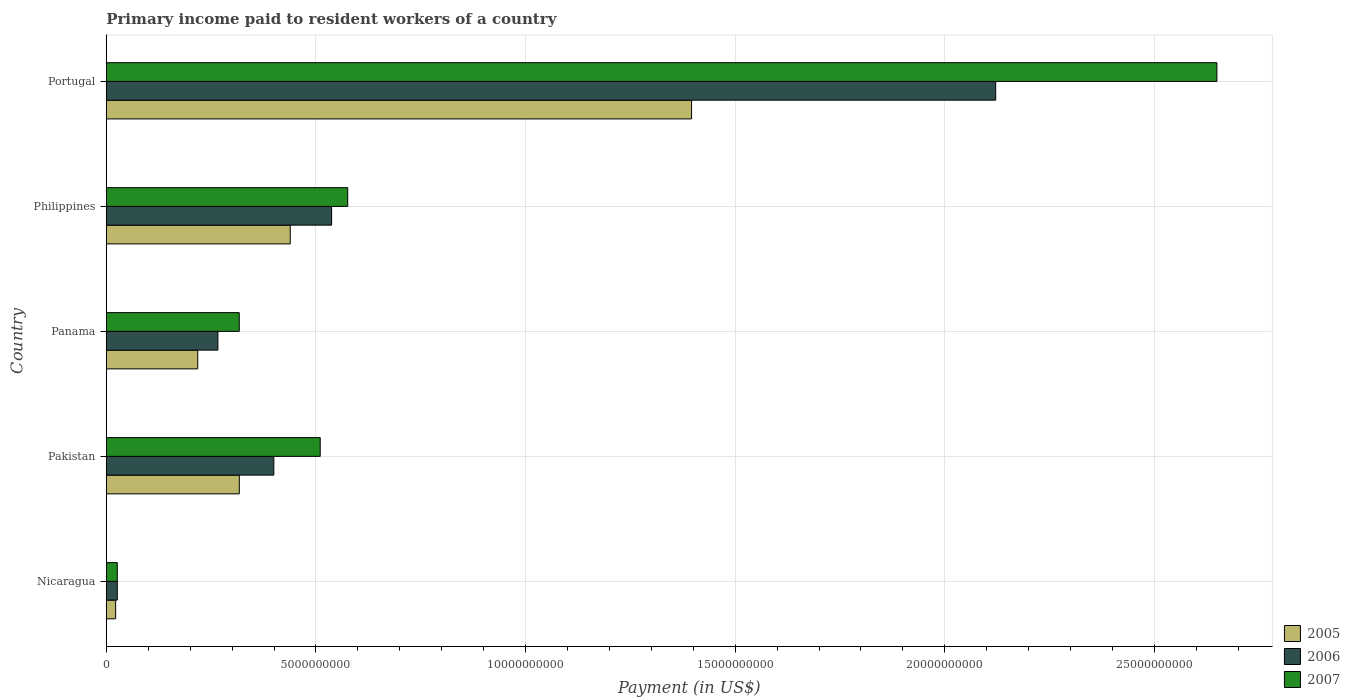How many groups of bars are there?
Your answer should be compact. 5. Are the number of bars per tick equal to the number of legend labels?
Your answer should be very brief. Yes. Are the number of bars on each tick of the Y-axis equal?
Ensure brevity in your answer.  Yes. How many bars are there on the 3rd tick from the top?
Offer a terse response. 3. In how many cases, is the number of bars for a given country not equal to the number of legend labels?
Keep it short and to the point. 0. What is the amount paid to workers in 2006 in Panama?
Offer a very short reply. 2.66e+09. Across all countries, what is the maximum amount paid to workers in 2007?
Keep it short and to the point. 2.65e+1. Across all countries, what is the minimum amount paid to workers in 2005?
Your response must be concise. 2.22e+08. In which country was the amount paid to workers in 2005 maximum?
Offer a very short reply. Portugal. In which country was the amount paid to workers in 2007 minimum?
Your answer should be very brief. Nicaragua. What is the total amount paid to workers in 2007 in the graph?
Give a very brief answer. 4.08e+1. What is the difference between the amount paid to workers in 2006 in Panama and that in Philippines?
Offer a very short reply. -2.71e+09. What is the difference between the amount paid to workers in 2007 in Pakistan and the amount paid to workers in 2006 in Portugal?
Your answer should be very brief. -1.61e+1. What is the average amount paid to workers in 2006 per country?
Keep it short and to the point. 6.70e+09. What is the difference between the amount paid to workers in 2005 and amount paid to workers in 2007 in Pakistan?
Offer a very short reply. -1.93e+09. What is the ratio of the amount paid to workers in 2005 in Pakistan to that in Philippines?
Your response must be concise. 0.72. What is the difference between the highest and the second highest amount paid to workers in 2007?
Provide a succinct answer. 2.07e+1. What is the difference between the highest and the lowest amount paid to workers in 2007?
Offer a very short reply. 2.62e+1. What does the 1st bar from the top in Pakistan represents?
Offer a terse response. 2007. What does the 2nd bar from the bottom in Portugal represents?
Provide a succinct answer. 2006. How many bars are there?
Your response must be concise. 15. What is the difference between two consecutive major ticks on the X-axis?
Provide a short and direct response. 5.00e+09. Are the values on the major ticks of X-axis written in scientific E-notation?
Your answer should be very brief. No. Does the graph contain any zero values?
Ensure brevity in your answer.  No. Where does the legend appear in the graph?
Give a very brief answer. Bottom right. How many legend labels are there?
Your response must be concise. 3. What is the title of the graph?
Keep it short and to the point. Primary income paid to resident workers of a country. Does "1987" appear as one of the legend labels in the graph?
Give a very brief answer. No. What is the label or title of the X-axis?
Keep it short and to the point. Payment (in US$). What is the Payment (in US$) in 2005 in Nicaragua?
Make the answer very short. 2.22e+08. What is the Payment (in US$) in 2006 in Nicaragua?
Provide a succinct answer. 2.62e+08. What is the Payment (in US$) of 2007 in Nicaragua?
Offer a very short reply. 2.61e+08. What is the Payment (in US$) of 2005 in Pakistan?
Provide a succinct answer. 3.17e+09. What is the Payment (in US$) of 2006 in Pakistan?
Offer a terse response. 4.00e+09. What is the Payment (in US$) in 2007 in Pakistan?
Make the answer very short. 5.10e+09. What is the Payment (in US$) in 2005 in Panama?
Offer a very short reply. 2.18e+09. What is the Payment (in US$) in 2006 in Panama?
Your answer should be very brief. 2.66e+09. What is the Payment (in US$) of 2007 in Panama?
Ensure brevity in your answer.  3.17e+09. What is the Payment (in US$) in 2005 in Philippines?
Ensure brevity in your answer.  4.39e+09. What is the Payment (in US$) in 2006 in Philippines?
Offer a terse response. 5.37e+09. What is the Payment (in US$) of 2007 in Philippines?
Offer a terse response. 5.76e+09. What is the Payment (in US$) in 2005 in Portugal?
Offer a very short reply. 1.40e+1. What is the Payment (in US$) in 2006 in Portugal?
Your response must be concise. 2.12e+1. What is the Payment (in US$) of 2007 in Portugal?
Provide a succinct answer. 2.65e+1. Across all countries, what is the maximum Payment (in US$) in 2005?
Provide a succinct answer. 1.40e+1. Across all countries, what is the maximum Payment (in US$) in 2006?
Ensure brevity in your answer.  2.12e+1. Across all countries, what is the maximum Payment (in US$) in 2007?
Provide a short and direct response. 2.65e+1. Across all countries, what is the minimum Payment (in US$) in 2005?
Give a very brief answer. 2.22e+08. Across all countries, what is the minimum Payment (in US$) of 2006?
Keep it short and to the point. 2.62e+08. Across all countries, what is the minimum Payment (in US$) in 2007?
Provide a short and direct response. 2.61e+08. What is the total Payment (in US$) of 2005 in the graph?
Your answer should be very brief. 2.39e+1. What is the total Payment (in US$) in 2006 in the graph?
Offer a very short reply. 3.35e+1. What is the total Payment (in US$) of 2007 in the graph?
Offer a terse response. 4.08e+1. What is the difference between the Payment (in US$) in 2005 in Nicaragua and that in Pakistan?
Make the answer very short. -2.95e+09. What is the difference between the Payment (in US$) of 2006 in Nicaragua and that in Pakistan?
Offer a very short reply. -3.73e+09. What is the difference between the Payment (in US$) in 2007 in Nicaragua and that in Pakistan?
Offer a very short reply. -4.84e+09. What is the difference between the Payment (in US$) of 2005 in Nicaragua and that in Panama?
Offer a terse response. -1.96e+09. What is the difference between the Payment (in US$) of 2006 in Nicaragua and that in Panama?
Offer a terse response. -2.40e+09. What is the difference between the Payment (in US$) in 2007 in Nicaragua and that in Panama?
Keep it short and to the point. -2.91e+09. What is the difference between the Payment (in US$) in 2005 in Nicaragua and that in Philippines?
Provide a succinct answer. -4.17e+09. What is the difference between the Payment (in US$) of 2006 in Nicaragua and that in Philippines?
Offer a very short reply. -5.11e+09. What is the difference between the Payment (in US$) of 2007 in Nicaragua and that in Philippines?
Offer a terse response. -5.50e+09. What is the difference between the Payment (in US$) of 2005 in Nicaragua and that in Portugal?
Your answer should be very brief. -1.37e+1. What is the difference between the Payment (in US$) of 2006 in Nicaragua and that in Portugal?
Offer a terse response. -2.10e+1. What is the difference between the Payment (in US$) of 2007 in Nicaragua and that in Portugal?
Provide a short and direct response. -2.62e+1. What is the difference between the Payment (in US$) of 2005 in Pakistan and that in Panama?
Make the answer very short. 9.92e+08. What is the difference between the Payment (in US$) in 2006 in Pakistan and that in Panama?
Offer a terse response. 1.33e+09. What is the difference between the Payment (in US$) of 2007 in Pakistan and that in Panama?
Your answer should be very brief. 1.93e+09. What is the difference between the Payment (in US$) of 2005 in Pakistan and that in Philippines?
Your answer should be compact. -1.22e+09. What is the difference between the Payment (in US$) in 2006 in Pakistan and that in Philippines?
Offer a very short reply. -1.38e+09. What is the difference between the Payment (in US$) of 2007 in Pakistan and that in Philippines?
Offer a terse response. -6.56e+08. What is the difference between the Payment (in US$) in 2005 in Pakistan and that in Portugal?
Provide a succinct answer. -1.08e+1. What is the difference between the Payment (in US$) in 2006 in Pakistan and that in Portugal?
Your answer should be compact. -1.72e+1. What is the difference between the Payment (in US$) of 2007 in Pakistan and that in Portugal?
Offer a very short reply. -2.14e+1. What is the difference between the Payment (in US$) in 2005 in Panama and that in Philippines?
Your answer should be compact. -2.21e+09. What is the difference between the Payment (in US$) in 2006 in Panama and that in Philippines?
Provide a short and direct response. -2.71e+09. What is the difference between the Payment (in US$) of 2007 in Panama and that in Philippines?
Offer a very short reply. -2.59e+09. What is the difference between the Payment (in US$) in 2005 in Panama and that in Portugal?
Provide a short and direct response. -1.18e+1. What is the difference between the Payment (in US$) of 2006 in Panama and that in Portugal?
Your answer should be compact. -1.86e+1. What is the difference between the Payment (in US$) of 2007 in Panama and that in Portugal?
Give a very brief answer. -2.33e+1. What is the difference between the Payment (in US$) in 2005 in Philippines and that in Portugal?
Your answer should be very brief. -9.57e+09. What is the difference between the Payment (in US$) of 2006 in Philippines and that in Portugal?
Provide a short and direct response. -1.58e+1. What is the difference between the Payment (in US$) of 2007 in Philippines and that in Portugal?
Your answer should be very brief. -2.07e+1. What is the difference between the Payment (in US$) in 2005 in Nicaragua and the Payment (in US$) in 2006 in Pakistan?
Keep it short and to the point. -3.77e+09. What is the difference between the Payment (in US$) in 2005 in Nicaragua and the Payment (in US$) in 2007 in Pakistan?
Give a very brief answer. -4.88e+09. What is the difference between the Payment (in US$) of 2006 in Nicaragua and the Payment (in US$) of 2007 in Pakistan?
Your answer should be compact. -4.84e+09. What is the difference between the Payment (in US$) of 2005 in Nicaragua and the Payment (in US$) of 2006 in Panama?
Make the answer very short. -2.44e+09. What is the difference between the Payment (in US$) of 2005 in Nicaragua and the Payment (in US$) of 2007 in Panama?
Provide a succinct answer. -2.95e+09. What is the difference between the Payment (in US$) of 2006 in Nicaragua and the Payment (in US$) of 2007 in Panama?
Keep it short and to the point. -2.91e+09. What is the difference between the Payment (in US$) of 2005 in Nicaragua and the Payment (in US$) of 2006 in Philippines?
Offer a very short reply. -5.15e+09. What is the difference between the Payment (in US$) of 2005 in Nicaragua and the Payment (in US$) of 2007 in Philippines?
Offer a terse response. -5.54e+09. What is the difference between the Payment (in US$) of 2006 in Nicaragua and the Payment (in US$) of 2007 in Philippines?
Provide a short and direct response. -5.50e+09. What is the difference between the Payment (in US$) in 2005 in Nicaragua and the Payment (in US$) in 2006 in Portugal?
Your answer should be compact. -2.10e+1. What is the difference between the Payment (in US$) in 2005 in Nicaragua and the Payment (in US$) in 2007 in Portugal?
Offer a very short reply. -2.63e+1. What is the difference between the Payment (in US$) of 2006 in Nicaragua and the Payment (in US$) of 2007 in Portugal?
Your answer should be very brief. -2.62e+1. What is the difference between the Payment (in US$) in 2005 in Pakistan and the Payment (in US$) in 2006 in Panama?
Your answer should be compact. 5.11e+08. What is the difference between the Payment (in US$) in 2005 in Pakistan and the Payment (in US$) in 2007 in Panama?
Give a very brief answer. 1.40e+06. What is the difference between the Payment (in US$) of 2006 in Pakistan and the Payment (in US$) of 2007 in Panama?
Your answer should be very brief. 8.25e+08. What is the difference between the Payment (in US$) in 2005 in Pakistan and the Payment (in US$) in 2006 in Philippines?
Offer a very short reply. -2.20e+09. What is the difference between the Payment (in US$) of 2005 in Pakistan and the Payment (in US$) of 2007 in Philippines?
Your response must be concise. -2.59e+09. What is the difference between the Payment (in US$) of 2006 in Pakistan and the Payment (in US$) of 2007 in Philippines?
Make the answer very short. -1.76e+09. What is the difference between the Payment (in US$) of 2005 in Pakistan and the Payment (in US$) of 2006 in Portugal?
Your answer should be very brief. -1.80e+1. What is the difference between the Payment (in US$) in 2005 in Pakistan and the Payment (in US$) in 2007 in Portugal?
Keep it short and to the point. -2.33e+1. What is the difference between the Payment (in US$) of 2006 in Pakistan and the Payment (in US$) of 2007 in Portugal?
Offer a very short reply. -2.25e+1. What is the difference between the Payment (in US$) of 2005 in Panama and the Payment (in US$) of 2006 in Philippines?
Offer a terse response. -3.19e+09. What is the difference between the Payment (in US$) of 2005 in Panama and the Payment (in US$) of 2007 in Philippines?
Your response must be concise. -3.58e+09. What is the difference between the Payment (in US$) of 2006 in Panama and the Payment (in US$) of 2007 in Philippines?
Your answer should be compact. -3.10e+09. What is the difference between the Payment (in US$) of 2005 in Panama and the Payment (in US$) of 2006 in Portugal?
Your response must be concise. -1.90e+1. What is the difference between the Payment (in US$) of 2005 in Panama and the Payment (in US$) of 2007 in Portugal?
Keep it short and to the point. -2.43e+1. What is the difference between the Payment (in US$) of 2006 in Panama and the Payment (in US$) of 2007 in Portugal?
Provide a succinct answer. -2.38e+1. What is the difference between the Payment (in US$) in 2005 in Philippines and the Payment (in US$) in 2006 in Portugal?
Make the answer very short. -1.68e+1. What is the difference between the Payment (in US$) of 2005 in Philippines and the Payment (in US$) of 2007 in Portugal?
Your answer should be compact. -2.21e+1. What is the difference between the Payment (in US$) in 2006 in Philippines and the Payment (in US$) in 2007 in Portugal?
Provide a succinct answer. -2.11e+1. What is the average Payment (in US$) in 2005 per country?
Keep it short and to the point. 4.78e+09. What is the average Payment (in US$) of 2006 per country?
Your answer should be very brief. 6.70e+09. What is the average Payment (in US$) in 2007 per country?
Make the answer very short. 8.16e+09. What is the difference between the Payment (in US$) in 2005 and Payment (in US$) in 2006 in Nicaragua?
Provide a short and direct response. -3.95e+07. What is the difference between the Payment (in US$) of 2005 and Payment (in US$) of 2007 in Nicaragua?
Offer a very short reply. -3.94e+07. What is the difference between the Payment (in US$) in 2006 and Payment (in US$) in 2007 in Nicaragua?
Your answer should be compact. 1.00e+05. What is the difference between the Payment (in US$) in 2005 and Payment (in US$) in 2006 in Pakistan?
Provide a succinct answer. -8.23e+08. What is the difference between the Payment (in US$) of 2005 and Payment (in US$) of 2007 in Pakistan?
Ensure brevity in your answer.  -1.93e+09. What is the difference between the Payment (in US$) in 2006 and Payment (in US$) in 2007 in Pakistan?
Your response must be concise. -1.11e+09. What is the difference between the Payment (in US$) of 2005 and Payment (in US$) of 2006 in Panama?
Your response must be concise. -4.81e+08. What is the difference between the Payment (in US$) of 2005 and Payment (in US$) of 2007 in Panama?
Make the answer very short. -9.90e+08. What is the difference between the Payment (in US$) of 2006 and Payment (in US$) of 2007 in Panama?
Give a very brief answer. -5.09e+08. What is the difference between the Payment (in US$) in 2005 and Payment (in US$) in 2006 in Philippines?
Provide a short and direct response. -9.87e+08. What is the difference between the Payment (in US$) in 2005 and Payment (in US$) in 2007 in Philippines?
Keep it short and to the point. -1.37e+09. What is the difference between the Payment (in US$) of 2006 and Payment (in US$) of 2007 in Philippines?
Offer a terse response. -3.84e+08. What is the difference between the Payment (in US$) in 2005 and Payment (in US$) in 2006 in Portugal?
Offer a very short reply. -7.25e+09. What is the difference between the Payment (in US$) of 2005 and Payment (in US$) of 2007 in Portugal?
Provide a succinct answer. -1.25e+1. What is the difference between the Payment (in US$) in 2006 and Payment (in US$) in 2007 in Portugal?
Keep it short and to the point. -5.28e+09. What is the ratio of the Payment (in US$) of 2005 in Nicaragua to that in Pakistan?
Offer a terse response. 0.07. What is the ratio of the Payment (in US$) in 2006 in Nicaragua to that in Pakistan?
Ensure brevity in your answer.  0.07. What is the ratio of the Payment (in US$) of 2007 in Nicaragua to that in Pakistan?
Keep it short and to the point. 0.05. What is the ratio of the Payment (in US$) in 2005 in Nicaragua to that in Panama?
Provide a short and direct response. 0.1. What is the ratio of the Payment (in US$) in 2006 in Nicaragua to that in Panama?
Provide a short and direct response. 0.1. What is the ratio of the Payment (in US$) in 2007 in Nicaragua to that in Panama?
Provide a succinct answer. 0.08. What is the ratio of the Payment (in US$) in 2005 in Nicaragua to that in Philippines?
Give a very brief answer. 0.05. What is the ratio of the Payment (in US$) in 2006 in Nicaragua to that in Philippines?
Offer a very short reply. 0.05. What is the ratio of the Payment (in US$) of 2007 in Nicaragua to that in Philippines?
Give a very brief answer. 0.05. What is the ratio of the Payment (in US$) of 2005 in Nicaragua to that in Portugal?
Provide a succinct answer. 0.02. What is the ratio of the Payment (in US$) of 2006 in Nicaragua to that in Portugal?
Your answer should be very brief. 0.01. What is the ratio of the Payment (in US$) of 2007 in Nicaragua to that in Portugal?
Your response must be concise. 0.01. What is the ratio of the Payment (in US$) of 2005 in Pakistan to that in Panama?
Make the answer very short. 1.45. What is the ratio of the Payment (in US$) in 2006 in Pakistan to that in Panama?
Ensure brevity in your answer.  1.5. What is the ratio of the Payment (in US$) of 2007 in Pakistan to that in Panama?
Your answer should be very brief. 1.61. What is the ratio of the Payment (in US$) of 2005 in Pakistan to that in Philippines?
Provide a succinct answer. 0.72. What is the ratio of the Payment (in US$) of 2006 in Pakistan to that in Philippines?
Your answer should be compact. 0.74. What is the ratio of the Payment (in US$) in 2007 in Pakistan to that in Philippines?
Ensure brevity in your answer.  0.89. What is the ratio of the Payment (in US$) in 2005 in Pakistan to that in Portugal?
Offer a terse response. 0.23. What is the ratio of the Payment (in US$) of 2006 in Pakistan to that in Portugal?
Your answer should be compact. 0.19. What is the ratio of the Payment (in US$) of 2007 in Pakistan to that in Portugal?
Offer a terse response. 0.19. What is the ratio of the Payment (in US$) in 2005 in Panama to that in Philippines?
Give a very brief answer. 0.5. What is the ratio of the Payment (in US$) in 2006 in Panama to that in Philippines?
Give a very brief answer. 0.5. What is the ratio of the Payment (in US$) of 2007 in Panama to that in Philippines?
Keep it short and to the point. 0.55. What is the ratio of the Payment (in US$) in 2005 in Panama to that in Portugal?
Give a very brief answer. 0.16. What is the ratio of the Payment (in US$) of 2006 in Panama to that in Portugal?
Provide a succinct answer. 0.13. What is the ratio of the Payment (in US$) in 2007 in Panama to that in Portugal?
Your answer should be compact. 0.12. What is the ratio of the Payment (in US$) of 2005 in Philippines to that in Portugal?
Provide a succinct answer. 0.31. What is the ratio of the Payment (in US$) in 2006 in Philippines to that in Portugal?
Keep it short and to the point. 0.25. What is the ratio of the Payment (in US$) in 2007 in Philippines to that in Portugal?
Your response must be concise. 0.22. What is the difference between the highest and the second highest Payment (in US$) of 2005?
Provide a short and direct response. 9.57e+09. What is the difference between the highest and the second highest Payment (in US$) in 2006?
Your answer should be compact. 1.58e+1. What is the difference between the highest and the second highest Payment (in US$) in 2007?
Your answer should be very brief. 2.07e+1. What is the difference between the highest and the lowest Payment (in US$) of 2005?
Your answer should be compact. 1.37e+1. What is the difference between the highest and the lowest Payment (in US$) in 2006?
Offer a terse response. 2.10e+1. What is the difference between the highest and the lowest Payment (in US$) of 2007?
Provide a short and direct response. 2.62e+1. 